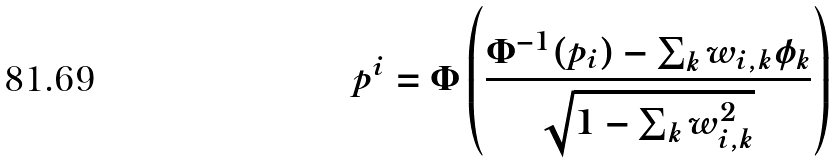Convert formula to latex. <formula><loc_0><loc_0><loc_500><loc_500>p ^ { i } = \Phi \left ( \frac { \Phi ^ { - 1 } ( p _ { i } ) - \sum _ { k } w _ { i , k } \phi _ { k } } { \sqrt { 1 - \sum _ { k } w _ { i , k } ^ { 2 } } } \right )</formula> 